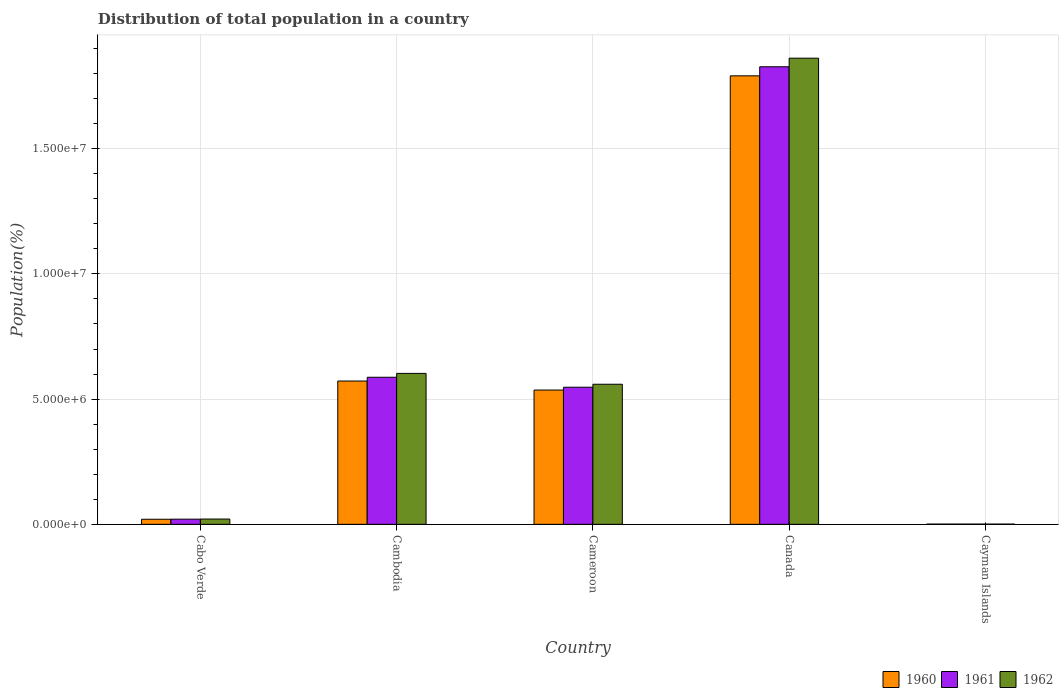How many different coloured bars are there?
Your answer should be very brief. 3. Are the number of bars on each tick of the X-axis equal?
Ensure brevity in your answer.  Yes. What is the label of the 4th group of bars from the left?
Your answer should be compact. Canada. What is the population of in 1960 in Canada?
Your answer should be very brief. 1.79e+07. Across all countries, what is the maximum population of in 1961?
Offer a very short reply. 1.83e+07. Across all countries, what is the minimum population of in 1962?
Give a very brief answer. 8142. In which country was the population of in 1961 minimum?
Provide a succinct answer. Cayman Islands. What is the total population of in 1962 in the graph?
Make the answer very short. 3.05e+07. What is the difference between the population of in 1960 in Cabo Verde and that in Cameroon?
Ensure brevity in your answer.  -5.16e+06. What is the difference between the population of in 1961 in Cabo Verde and the population of in 1960 in Cayman Islands?
Your answer should be very brief. 1.98e+05. What is the average population of in 1962 per country?
Offer a very short reply. 6.09e+06. What is the difference between the population of of/in 1960 and population of of/in 1961 in Canada?
Your answer should be compact. -3.62e+05. What is the ratio of the population of in 1961 in Cambodia to that in Cayman Islands?
Your answer should be very brief. 731.65. Is the difference between the population of in 1960 in Canada and Cayman Islands greater than the difference between the population of in 1961 in Canada and Cayman Islands?
Provide a short and direct response. No. What is the difference between the highest and the second highest population of in 1961?
Provide a short and direct response. 1.28e+07. What is the difference between the highest and the lowest population of in 1960?
Your answer should be very brief. 1.79e+07. Is the sum of the population of in 1962 in Cabo Verde and Cayman Islands greater than the maximum population of in 1961 across all countries?
Your answer should be very brief. No. What does the 3rd bar from the right in Cameroon represents?
Your answer should be compact. 1960. How many bars are there?
Keep it short and to the point. 15. Are the values on the major ticks of Y-axis written in scientific E-notation?
Make the answer very short. Yes. Where does the legend appear in the graph?
Provide a succinct answer. Bottom right. How are the legend labels stacked?
Provide a succinct answer. Horizontal. What is the title of the graph?
Ensure brevity in your answer.  Distribution of total population in a country. What is the label or title of the X-axis?
Provide a short and direct response. Country. What is the label or title of the Y-axis?
Your answer should be very brief. Population(%). What is the Population(%) of 1960 in Cabo Verde?
Your answer should be very brief. 2.02e+05. What is the Population(%) in 1961 in Cabo Verde?
Keep it short and to the point. 2.06e+05. What is the Population(%) in 1962 in Cabo Verde?
Provide a short and direct response. 2.11e+05. What is the Population(%) in 1960 in Cambodia?
Your response must be concise. 5.72e+06. What is the Population(%) of 1961 in Cambodia?
Your answer should be compact. 5.87e+06. What is the Population(%) of 1962 in Cambodia?
Keep it short and to the point. 6.03e+06. What is the Population(%) in 1960 in Cameroon?
Provide a succinct answer. 5.36e+06. What is the Population(%) of 1961 in Cameroon?
Keep it short and to the point. 5.47e+06. What is the Population(%) in 1962 in Cameroon?
Keep it short and to the point. 5.59e+06. What is the Population(%) in 1960 in Canada?
Your answer should be compact. 1.79e+07. What is the Population(%) in 1961 in Canada?
Give a very brief answer. 1.83e+07. What is the Population(%) of 1962 in Canada?
Give a very brief answer. 1.86e+07. What is the Population(%) in 1960 in Cayman Islands?
Your response must be concise. 7867. What is the Population(%) of 1961 in Cayman Islands?
Ensure brevity in your answer.  8026. What is the Population(%) of 1962 in Cayman Islands?
Ensure brevity in your answer.  8142. Across all countries, what is the maximum Population(%) of 1960?
Your answer should be very brief. 1.79e+07. Across all countries, what is the maximum Population(%) in 1961?
Your response must be concise. 1.83e+07. Across all countries, what is the maximum Population(%) in 1962?
Your answer should be compact. 1.86e+07. Across all countries, what is the minimum Population(%) in 1960?
Ensure brevity in your answer.  7867. Across all countries, what is the minimum Population(%) in 1961?
Your answer should be very brief. 8026. Across all countries, what is the minimum Population(%) in 1962?
Ensure brevity in your answer.  8142. What is the total Population(%) in 1960 in the graph?
Make the answer very short. 2.92e+07. What is the total Population(%) of 1961 in the graph?
Provide a short and direct response. 2.98e+07. What is the total Population(%) of 1962 in the graph?
Provide a succinct answer. 3.05e+07. What is the difference between the Population(%) of 1960 in Cabo Verde and that in Cambodia?
Make the answer very short. -5.52e+06. What is the difference between the Population(%) of 1961 in Cabo Verde and that in Cambodia?
Make the answer very short. -5.67e+06. What is the difference between the Population(%) of 1962 in Cabo Verde and that in Cambodia?
Your answer should be very brief. -5.82e+06. What is the difference between the Population(%) in 1960 in Cabo Verde and that in Cameroon?
Ensure brevity in your answer.  -5.16e+06. What is the difference between the Population(%) in 1961 in Cabo Verde and that in Cameroon?
Give a very brief answer. -5.27e+06. What is the difference between the Population(%) of 1962 in Cabo Verde and that in Cameroon?
Offer a terse response. -5.38e+06. What is the difference between the Population(%) of 1960 in Cabo Verde and that in Canada?
Your answer should be very brief. -1.77e+07. What is the difference between the Population(%) of 1961 in Cabo Verde and that in Canada?
Give a very brief answer. -1.81e+07. What is the difference between the Population(%) in 1962 in Cabo Verde and that in Canada?
Make the answer very short. -1.84e+07. What is the difference between the Population(%) in 1960 in Cabo Verde and that in Cayman Islands?
Offer a terse response. 1.94e+05. What is the difference between the Population(%) of 1961 in Cabo Verde and that in Cayman Islands?
Your answer should be compact. 1.98e+05. What is the difference between the Population(%) in 1962 in Cabo Verde and that in Cayman Islands?
Your answer should be very brief. 2.03e+05. What is the difference between the Population(%) in 1960 in Cambodia and that in Cameroon?
Offer a very short reply. 3.61e+05. What is the difference between the Population(%) of 1961 in Cambodia and that in Cameroon?
Offer a terse response. 3.98e+05. What is the difference between the Population(%) of 1962 in Cambodia and that in Cameroon?
Make the answer very short. 4.33e+05. What is the difference between the Population(%) in 1960 in Cambodia and that in Canada?
Offer a terse response. -1.22e+07. What is the difference between the Population(%) in 1961 in Cambodia and that in Canada?
Make the answer very short. -1.24e+07. What is the difference between the Population(%) of 1962 in Cambodia and that in Canada?
Your answer should be very brief. -1.26e+07. What is the difference between the Population(%) of 1960 in Cambodia and that in Cayman Islands?
Offer a terse response. 5.71e+06. What is the difference between the Population(%) in 1961 in Cambodia and that in Cayman Islands?
Provide a succinct answer. 5.86e+06. What is the difference between the Population(%) of 1962 in Cambodia and that in Cayman Islands?
Offer a very short reply. 6.02e+06. What is the difference between the Population(%) of 1960 in Cameroon and that in Canada?
Give a very brief answer. -1.25e+07. What is the difference between the Population(%) in 1961 in Cameroon and that in Canada?
Your response must be concise. -1.28e+07. What is the difference between the Population(%) in 1962 in Cameroon and that in Canada?
Offer a very short reply. -1.30e+07. What is the difference between the Population(%) of 1960 in Cameroon and that in Cayman Islands?
Offer a terse response. 5.35e+06. What is the difference between the Population(%) in 1961 in Cameroon and that in Cayman Islands?
Make the answer very short. 5.47e+06. What is the difference between the Population(%) in 1962 in Cameroon and that in Cayman Islands?
Provide a short and direct response. 5.59e+06. What is the difference between the Population(%) of 1960 in Canada and that in Cayman Islands?
Give a very brief answer. 1.79e+07. What is the difference between the Population(%) of 1961 in Canada and that in Cayman Islands?
Make the answer very short. 1.83e+07. What is the difference between the Population(%) of 1962 in Canada and that in Cayman Islands?
Your answer should be compact. 1.86e+07. What is the difference between the Population(%) of 1960 in Cabo Verde and the Population(%) of 1961 in Cambodia?
Your answer should be very brief. -5.67e+06. What is the difference between the Population(%) of 1960 in Cabo Verde and the Population(%) of 1962 in Cambodia?
Ensure brevity in your answer.  -5.82e+06. What is the difference between the Population(%) of 1961 in Cabo Verde and the Population(%) of 1962 in Cambodia?
Give a very brief answer. -5.82e+06. What is the difference between the Population(%) of 1960 in Cabo Verde and the Population(%) of 1961 in Cameroon?
Your response must be concise. -5.27e+06. What is the difference between the Population(%) in 1960 in Cabo Verde and the Population(%) in 1962 in Cameroon?
Give a very brief answer. -5.39e+06. What is the difference between the Population(%) of 1961 in Cabo Verde and the Population(%) of 1962 in Cameroon?
Keep it short and to the point. -5.39e+06. What is the difference between the Population(%) of 1960 in Cabo Verde and the Population(%) of 1961 in Canada?
Give a very brief answer. -1.81e+07. What is the difference between the Population(%) of 1960 in Cabo Verde and the Population(%) of 1962 in Canada?
Offer a terse response. -1.84e+07. What is the difference between the Population(%) of 1961 in Cabo Verde and the Population(%) of 1962 in Canada?
Make the answer very short. -1.84e+07. What is the difference between the Population(%) in 1960 in Cabo Verde and the Population(%) in 1961 in Cayman Islands?
Provide a succinct answer. 1.94e+05. What is the difference between the Population(%) in 1960 in Cabo Verde and the Population(%) in 1962 in Cayman Islands?
Ensure brevity in your answer.  1.94e+05. What is the difference between the Population(%) in 1961 in Cabo Verde and the Population(%) in 1962 in Cayman Islands?
Your answer should be very brief. 1.98e+05. What is the difference between the Population(%) in 1960 in Cambodia and the Population(%) in 1961 in Cameroon?
Your answer should be compact. 2.48e+05. What is the difference between the Population(%) of 1960 in Cambodia and the Population(%) of 1962 in Cameroon?
Provide a short and direct response. 1.29e+05. What is the difference between the Population(%) in 1961 in Cambodia and the Population(%) in 1962 in Cameroon?
Your answer should be compact. 2.78e+05. What is the difference between the Population(%) of 1960 in Cambodia and the Population(%) of 1961 in Canada?
Make the answer very short. -1.25e+07. What is the difference between the Population(%) in 1960 in Cambodia and the Population(%) in 1962 in Canada?
Provide a succinct answer. -1.29e+07. What is the difference between the Population(%) of 1961 in Cambodia and the Population(%) of 1962 in Canada?
Your answer should be very brief. -1.27e+07. What is the difference between the Population(%) in 1960 in Cambodia and the Population(%) in 1961 in Cayman Islands?
Make the answer very short. 5.71e+06. What is the difference between the Population(%) of 1960 in Cambodia and the Population(%) of 1962 in Cayman Islands?
Provide a short and direct response. 5.71e+06. What is the difference between the Population(%) in 1961 in Cambodia and the Population(%) in 1962 in Cayman Islands?
Your answer should be compact. 5.86e+06. What is the difference between the Population(%) in 1960 in Cameroon and the Population(%) in 1961 in Canada?
Provide a short and direct response. -1.29e+07. What is the difference between the Population(%) of 1960 in Cameroon and the Population(%) of 1962 in Canada?
Offer a very short reply. -1.33e+07. What is the difference between the Population(%) of 1961 in Cameroon and the Population(%) of 1962 in Canada?
Give a very brief answer. -1.31e+07. What is the difference between the Population(%) of 1960 in Cameroon and the Population(%) of 1961 in Cayman Islands?
Offer a terse response. 5.35e+06. What is the difference between the Population(%) of 1960 in Cameroon and the Population(%) of 1962 in Cayman Islands?
Offer a terse response. 5.35e+06. What is the difference between the Population(%) in 1961 in Cameroon and the Population(%) in 1962 in Cayman Islands?
Offer a terse response. 5.47e+06. What is the difference between the Population(%) of 1960 in Canada and the Population(%) of 1961 in Cayman Islands?
Provide a short and direct response. 1.79e+07. What is the difference between the Population(%) of 1960 in Canada and the Population(%) of 1962 in Cayman Islands?
Keep it short and to the point. 1.79e+07. What is the difference between the Population(%) of 1961 in Canada and the Population(%) of 1962 in Cayman Islands?
Keep it short and to the point. 1.83e+07. What is the average Population(%) of 1960 per country?
Provide a succinct answer. 5.84e+06. What is the average Population(%) in 1961 per country?
Provide a short and direct response. 5.97e+06. What is the average Population(%) of 1962 per country?
Provide a short and direct response. 6.09e+06. What is the difference between the Population(%) in 1960 and Population(%) in 1961 in Cabo Verde?
Your answer should be very brief. -3642. What is the difference between the Population(%) in 1960 and Population(%) in 1962 in Cabo Verde?
Ensure brevity in your answer.  -8550. What is the difference between the Population(%) in 1961 and Population(%) in 1962 in Cabo Verde?
Provide a short and direct response. -4908. What is the difference between the Population(%) in 1960 and Population(%) in 1961 in Cambodia?
Make the answer very short. -1.50e+05. What is the difference between the Population(%) in 1960 and Population(%) in 1962 in Cambodia?
Make the answer very short. -3.04e+05. What is the difference between the Population(%) of 1961 and Population(%) of 1962 in Cambodia?
Your answer should be compact. -1.54e+05. What is the difference between the Population(%) of 1960 and Population(%) of 1961 in Cameroon?
Provide a short and direct response. -1.13e+05. What is the difference between the Population(%) of 1960 and Population(%) of 1962 in Cameroon?
Ensure brevity in your answer.  -2.32e+05. What is the difference between the Population(%) in 1961 and Population(%) in 1962 in Cameroon?
Keep it short and to the point. -1.19e+05. What is the difference between the Population(%) in 1960 and Population(%) in 1961 in Canada?
Ensure brevity in your answer.  -3.62e+05. What is the difference between the Population(%) in 1960 and Population(%) in 1962 in Canada?
Keep it short and to the point. -7.05e+05. What is the difference between the Population(%) of 1961 and Population(%) of 1962 in Canada?
Your answer should be very brief. -3.43e+05. What is the difference between the Population(%) in 1960 and Population(%) in 1961 in Cayman Islands?
Provide a short and direct response. -159. What is the difference between the Population(%) in 1960 and Population(%) in 1962 in Cayman Islands?
Offer a terse response. -275. What is the difference between the Population(%) in 1961 and Population(%) in 1962 in Cayman Islands?
Keep it short and to the point. -116. What is the ratio of the Population(%) in 1960 in Cabo Verde to that in Cambodia?
Your answer should be compact. 0.04. What is the ratio of the Population(%) of 1961 in Cabo Verde to that in Cambodia?
Ensure brevity in your answer.  0.04. What is the ratio of the Population(%) of 1962 in Cabo Verde to that in Cambodia?
Your response must be concise. 0.04. What is the ratio of the Population(%) of 1960 in Cabo Verde to that in Cameroon?
Your response must be concise. 0.04. What is the ratio of the Population(%) in 1961 in Cabo Verde to that in Cameroon?
Provide a short and direct response. 0.04. What is the ratio of the Population(%) of 1962 in Cabo Verde to that in Cameroon?
Provide a short and direct response. 0.04. What is the ratio of the Population(%) of 1960 in Cabo Verde to that in Canada?
Offer a terse response. 0.01. What is the ratio of the Population(%) of 1961 in Cabo Verde to that in Canada?
Keep it short and to the point. 0.01. What is the ratio of the Population(%) of 1962 in Cabo Verde to that in Canada?
Give a very brief answer. 0.01. What is the ratio of the Population(%) in 1960 in Cabo Verde to that in Cayman Islands?
Your answer should be compact. 25.72. What is the ratio of the Population(%) in 1961 in Cabo Verde to that in Cayman Islands?
Make the answer very short. 25.66. What is the ratio of the Population(%) in 1962 in Cabo Verde to that in Cayman Islands?
Ensure brevity in your answer.  25.9. What is the ratio of the Population(%) in 1960 in Cambodia to that in Cameroon?
Your response must be concise. 1.07. What is the ratio of the Population(%) of 1961 in Cambodia to that in Cameroon?
Provide a short and direct response. 1.07. What is the ratio of the Population(%) in 1962 in Cambodia to that in Cameroon?
Your answer should be compact. 1.08. What is the ratio of the Population(%) of 1960 in Cambodia to that in Canada?
Give a very brief answer. 0.32. What is the ratio of the Population(%) of 1961 in Cambodia to that in Canada?
Provide a succinct answer. 0.32. What is the ratio of the Population(%) of 1962 in Cambodia to that in Canada?
Offer a terse response. 0.32. What is the ratio of the Population(%) of 1960 in Cambodia to that in Cayman Islands?
Keep it short and to the point. 727.39. What is the ratio of the Population(%) in 1961 in Cambodia to that in Cayman Islands?
Your answer should be compact. 731.65. What is the ratio of the Population(%) of 1962 in Cambodia to that in Cayman Islands?
Provide a short and direct response. 740.2. What is the ratio of the Population(%) in 1960 in Cameroon to that in Canada?
Give a very brief answer. 0.3. What is the ratio of the Population(%) in 1961 in Cameroon to that in Canada?
Your answer should be very brief. 0.3. What is the ratio of the Population(%) of 1962 in Cameroon to that in Canada?
Provide a short and direct response. 0.3. What is the ratio of the Population(%) of 1960 in Cameroon to that in Cayman Islands?
Ensure brevity in your answer.  681.5. What is the ratio of the Population(%) in 1961 in Cameroon to that in Cayman Islands?
Give a very brief answer. 682.1. What is the ratio of the Population(%) of 1962 in Cameroon to that in Cayman Islands?
Keep it short and to the point. 687.03. What is the ratio of the Population(%) of 1960 in Canada to that in Cayman Islands?
Provide a succinct answer. 2276.47. What is the ratio of the Population(%) of 1961 in Canada to that in Cayman Islands?
Make the answer very short. 2276.48. What is the ratio of the Population(%) of 1962 in Canada to that in Cayman Islands?
Offer a very short reply. 2286.17. What is the difference between the highest and the second highest Population(%) of 1960?
Make the answer very short. 1.22e+07. What is the difference between the highest and the second highest Population(%) in 1961?
Offer a terse response. 1.24e+07. What is the difference between the highest and the second highest Population(%) in 1962?
Provide a short and direct response. 1.26e+07. What is the difference between the highest and the lowest Population(%) of 1960?
Offer a terse response. 1.79e+07. What is the difference between the highest and the lowest Population(%) of 1961?
Give a very brief answer. 1.83e+07. What is the difference between the highest and the lowest Population(%) of 1962?
Offer a terse response. 1.86e+07. 